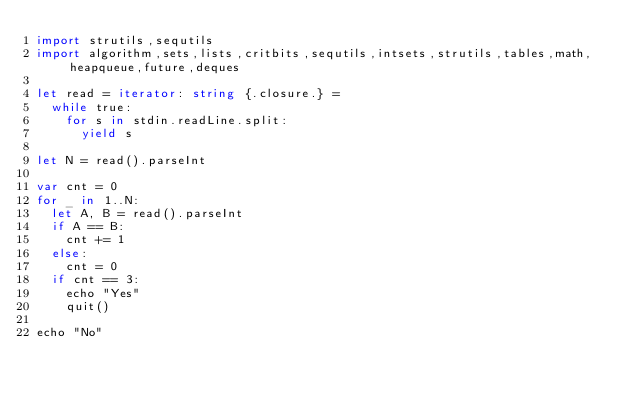Convert code to text. <code><loc_0><loc_0><loc_500><loc_500><_Nim_>import strutils,sequtils
import algorithm,sets,lists,critbits,sequtils,intsets,strutils,tables,math,heapqueue,future,deques

let read = iterator: string {.closure.} =
  while true:
    for s in stdin.readLine.split:
      yield s

let N = read().parseInt

var cnt = 0
for _ in 1..N:
  let A, B = read().parseInt
  if A == B:
    cnt += 1
  else:
    cnt = 0
  if cnt == 3:
    echo "Yes"
    quit()

echo "No"
</code> 